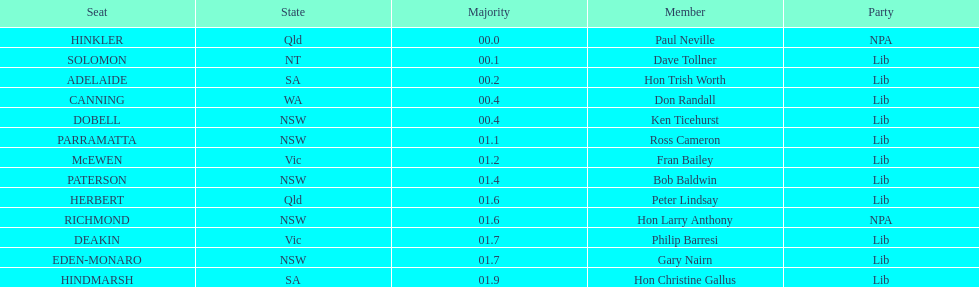Could you parse the entire table? {'header': ['Seat', 'State', 'Majority', 'Member', 'Party'], 'rows': [['HINKLER', 'Qld', '00.0', 'Paul Neville', 'NPA'], ['SOLOMON', 'NT', '00.1', 'Dave Tollner', 'Lib'], ['ADELAIDE', 'SA', '00.2', 'Hon Trish Worth', 'Lib'], ['CANNING', 'WA', '00.4', 'Don Randall', 'Lib'], ['DOBELL', 'NSW', '00.4', 'Ken Ticehurst', 'Lib'], ['PARRAMATTA', 'NSW', '01.1', 'Ross Cameron', 'Lib'], ['McEWEN', 'Vic', '01.2', 'Fran Bailey', 'Lib'], ['PATERSON', 'NSW', '01.4', 'Bob Baldwin', 'Lib'], ['HERBERT', 'Qld', '01.6', 'Peter Lindsay', 'Lib'], ['RICHMOND', 'NSW', '01.6', 'Hon Larry Anthony', 'NPA'], ['DEAKIN', 'Vic', '01.7', 'Philip Barresi', 'Lib'], ['EDEN-MONARO', 'NSW', '01.7', 'Gary Nairn', 'Lib'], ['HINDMARSH', 'SA', '01.9', 'Hon Christine Gallus', 'Lib']]} What was the complete majority figure for the dobell seat? 00.4. 